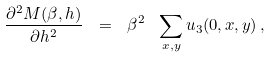Convert formula to latex. <formula><loc_0><loc_0><loc_500><loc_500>\frac { \partial ^ { 2 } M ( \beta , h ) } { \partial h ^ { 2 } } \ = \ \beta ^ { 2 } \ \sum _ { x , y } u _ { 3 } ( 0 , x , y ) \, ,</formula> 